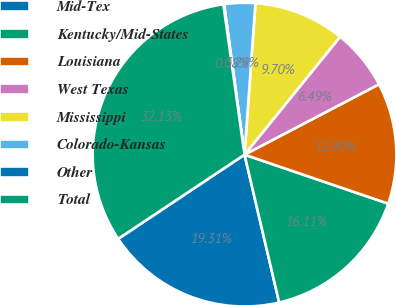Convert chart. <chart><loc_0><loc_0><loc_500><loc_500><pie_chart><fcel>Mid-Tex<fcel>Kentucky/Mid-States<fcel>Louisiana<fcel>West Texas<fcel>Mississippi<fcel>Colorado-Kansas<fcel>Other<fcel>Total<nl><fcel>19.31%<fcel>16.11%<fcel>12.9%<fcel>6.49%<fcel>9.7%<fcel>3.29%<fcel>0.08%<fcel>32.13%<nl></chart> 